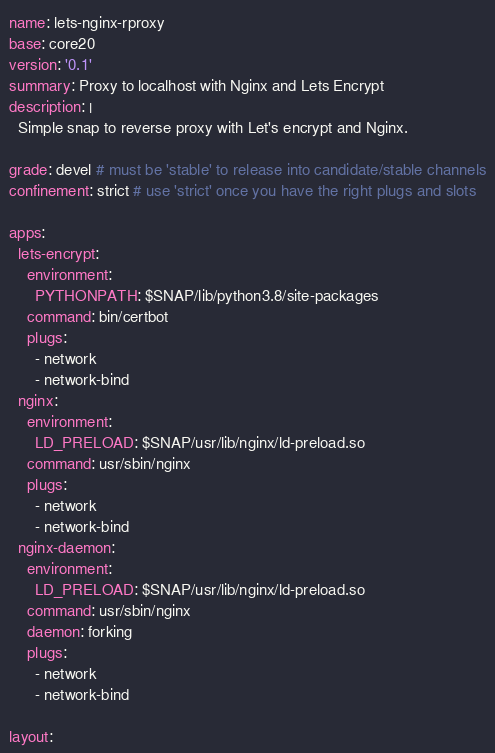<code> <loc_0><loc_0><loc_500><loc_500><_YAML_>name: lets-nginx-rproxy
base: core20
version: '0.1' 
summary: Proxy to localhost with Nginx and Lets Encrypt
description: |
  Simple snap to reverse proxy with Let's encrypt and Nginx.

grade: devel # must be 'stable' to release into candidate/stable channels
confinement: strict # use 'strict' once you have the right plugs and slots

apps:
  lets-encrypt:
    environment:
      PYTHONPATH: $SNAP/lib/python3.8/site-packages
    command: bin/certbot
    plugs:
      - network
      - network-bind
  nginx:
    environment:
      LD_PRELOAD: $SNAP/usr/lib/nginx/ld-preload.so
    command: usr/sbin/nginx
    plugs:
      - network
      - network-bind
  nginx-daemon:
    environment:
      LD_PRELOAD: $SNAP/usr/lib/nginx/ld-preload.so
    command: usr/sbin/nginx
    daemon: forking
    plugs:
      - network
      - network-bind

layout:</code> 